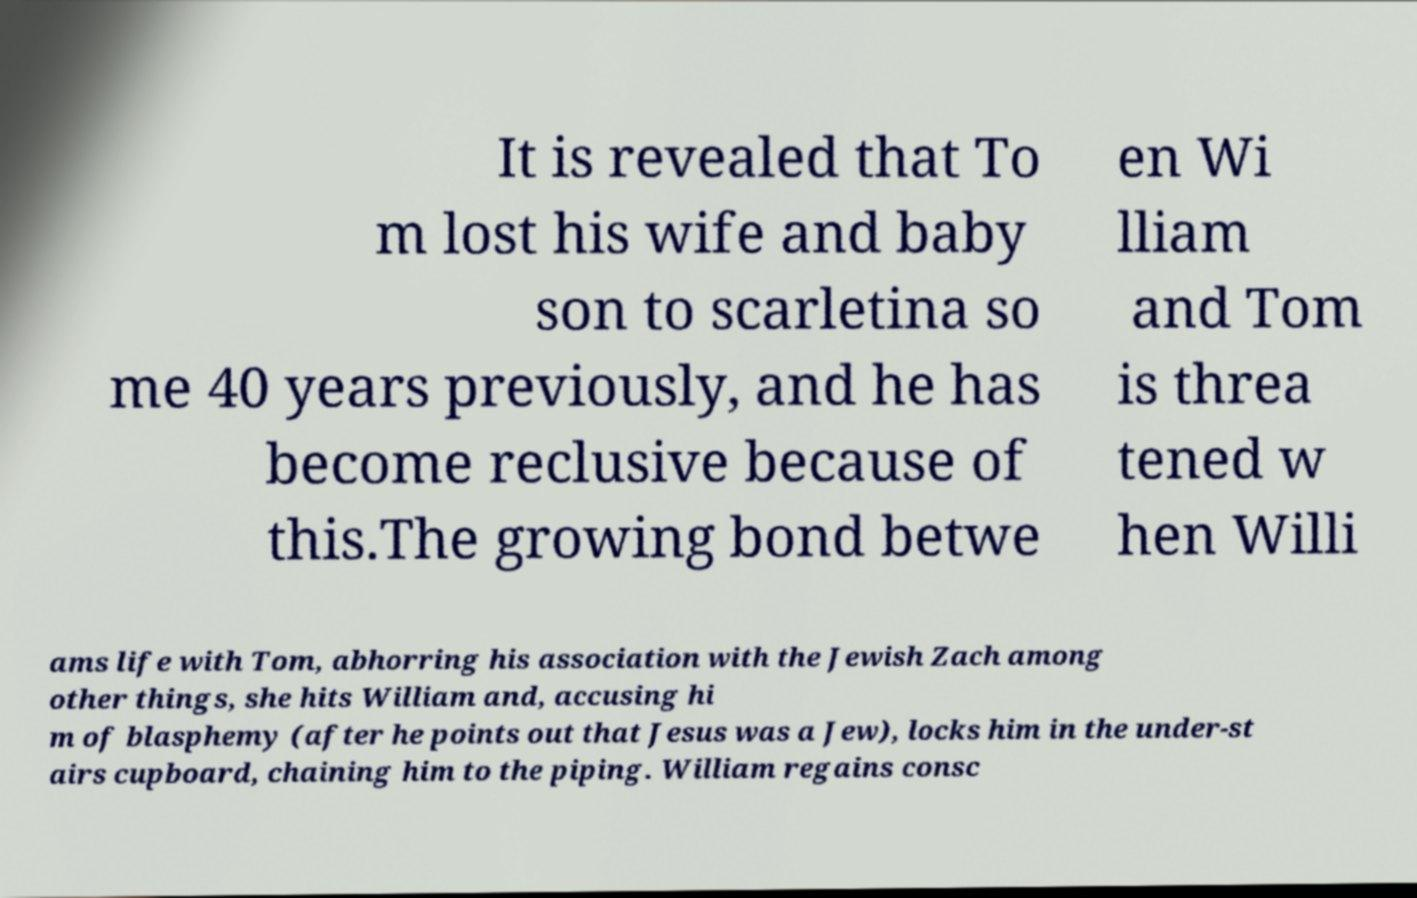Please read and relay the text visible in this image. What does it say? It is revealed that To m lost his wife and baby son to scarletina so me 40 years previously, and he has become reclusive because of this.The growing bond betwe en Wi lliam and Tom is threa tened w hen Willi ams life with Tom, abhorring his association with the Jewish Zach among other things, she hits William and, accusing hi m of blasphemy (after he points out that Jesus was a Jew), locks him in the under-st airs cupboard, chaining him to the piping. William regains consc 